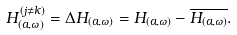Convert formula to latex. <formula><loc_0><loc_0><loc_500><loc_500>H _ { ( a , \omega ) } ^ { ( j \neq k ) } = \Delta H _ { ( a , \omega ) } = H _ { ( a , \omega ) } - \overline { H _ { ( a , \omega ) } } .</formula> 